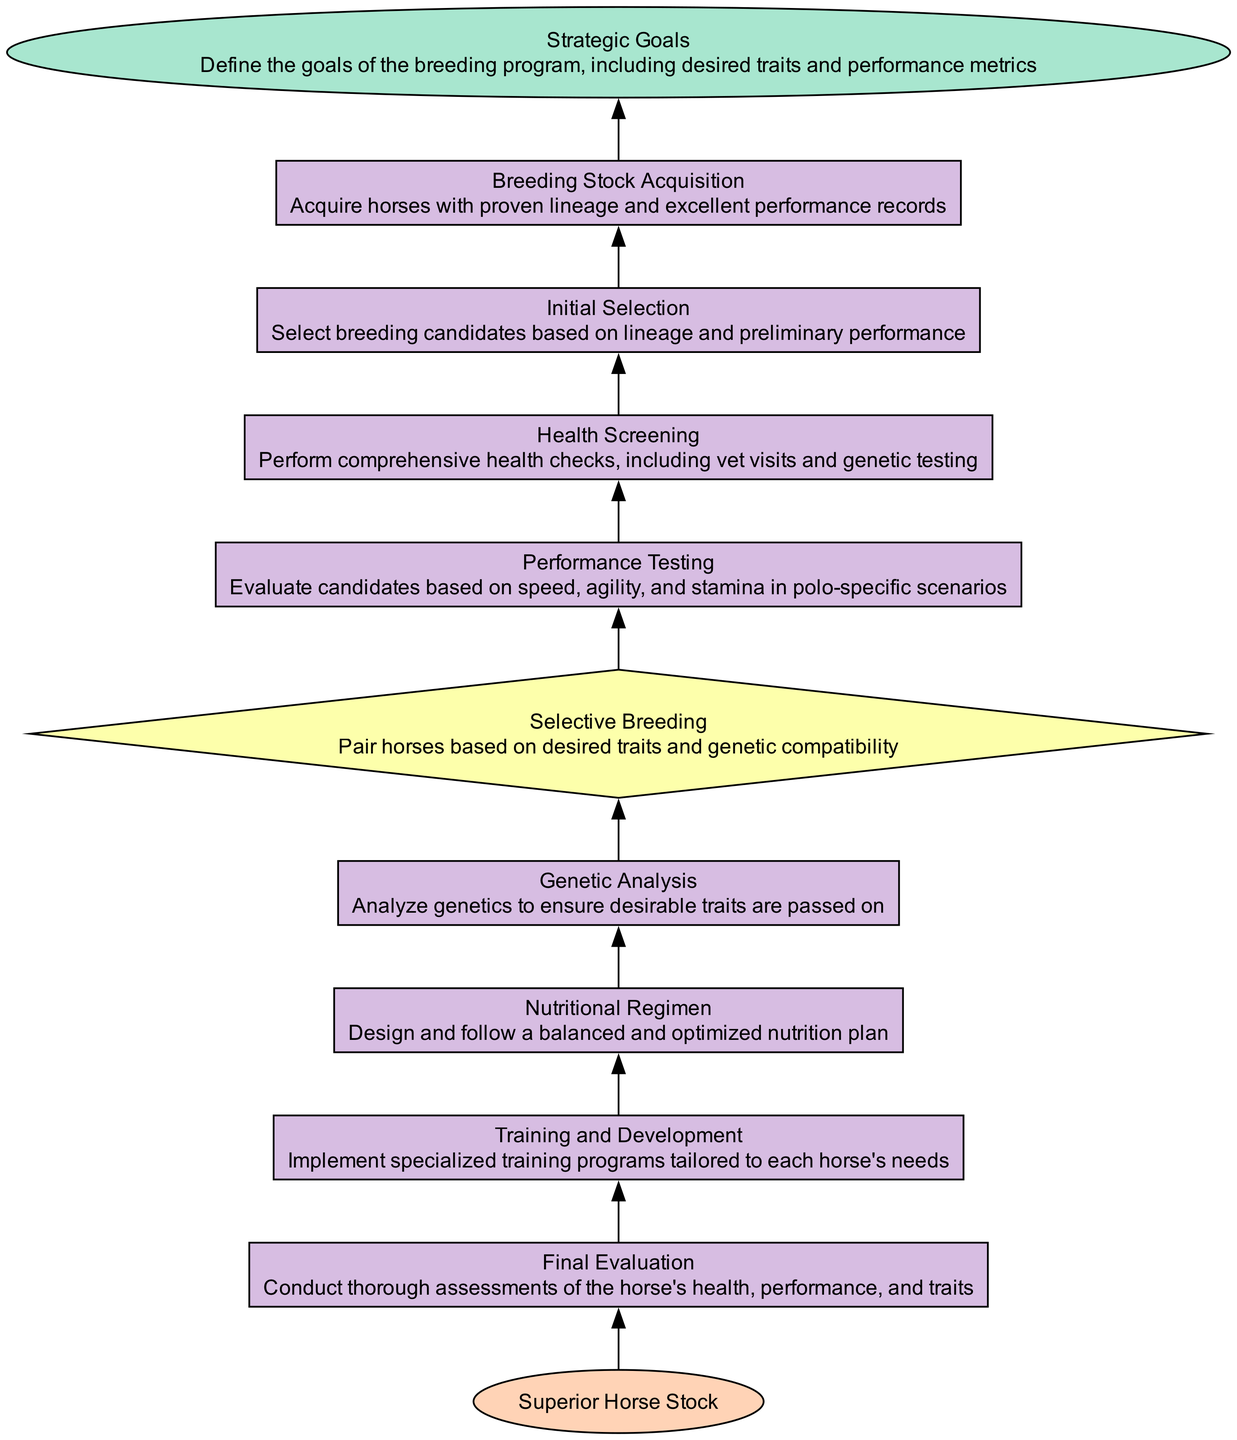What is the starting point of the breeding program flowchart? The starting point of the flowchart is labeled "Strategic Goals". It defines the overall goals of the breeding program, including the traits and performance metrics desired.
Answer: Strategic Goals How many total processes are in the flowchart? By counting the types of elements labeled as "process", there are a total of six processes: Final Evaluation, Training and Development, Nutritional Regimen, Genetic Analysis, Performance Testing, Health Screening, and Initial Selection.
Answer: Six Which node leads directly to Final Evaluation? The node that leads directly to Final Evaluation is "Training and Development". This indicates that after Training and Development has been implemented, the next step in the process is to evaluate the horses.
Answer: Training and Development What is the outcome after Final Evaluation? The outcome after Final Evaluation is the final goal, represented by "Superior Horse Stock". This shows that the evaluations culminate in achieving the goal of superior breeding.
Answer: Superior Horse Stock What is the purpose of Health Screening in the flowchart? Health Screening's purpose is to perform comprehensive health checks, including vet visits and genetic testing, which ensures that breeding candidates are healthy before proceeding to further assessments.
Answer: Perform comprehensive health checks Which process is undertaken before Performance Testing? The process undertaken before Performance Testing is Health Screening. The sequence indicates that only after thorough health checks can performance testing occur, ensuring the horses are fit for evaluation.
Answer: Health Screening What kind of analysis is performed in Genetic Analysis? In Genetic Analysis, an analysis of genetics is conducted to ensure desirable traits are passed on to offspring, supporting the goal of breeding superior horses.
Answer: Analyze genetics What decision comes before "Selective Breeding"? The decision that comes before "Selective Breeding" is "Initial Selection". This implies that horses are first selected as candidates based on their lineage and preliminary performance before selective breeding occurs.
Answer: Initial Selection What defines the criteria for "Selective Breeding"? The criteria for "Selective Breeding" is based on pairing horses according to desired traits and genetic compatibility, ensuring that the best qualities are combined in the breeding process.
Answer: Pair horses based on desired traits and genetic compatibility 